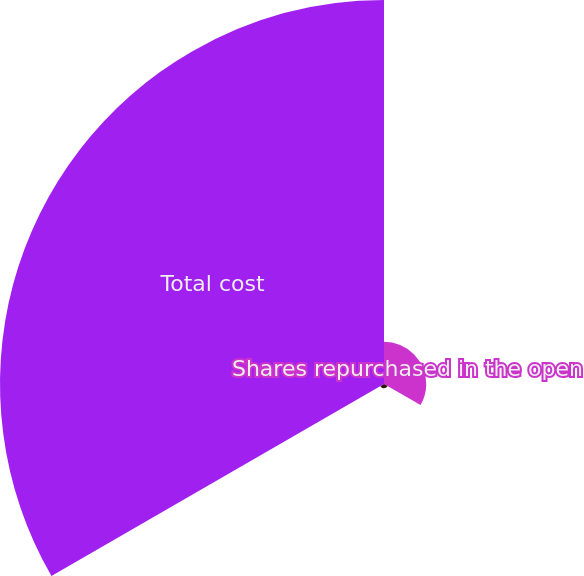Convert chart. <chart><loc_0><loc_0><loc_500><loc_500><pie_chart><fcel>Shares repurchased in the open<fcel>Average repurchase price per<fcel>Total cost<nl><fcel>9.81%<fcel>0.98%<fcel>89.21%<nl></chart> 